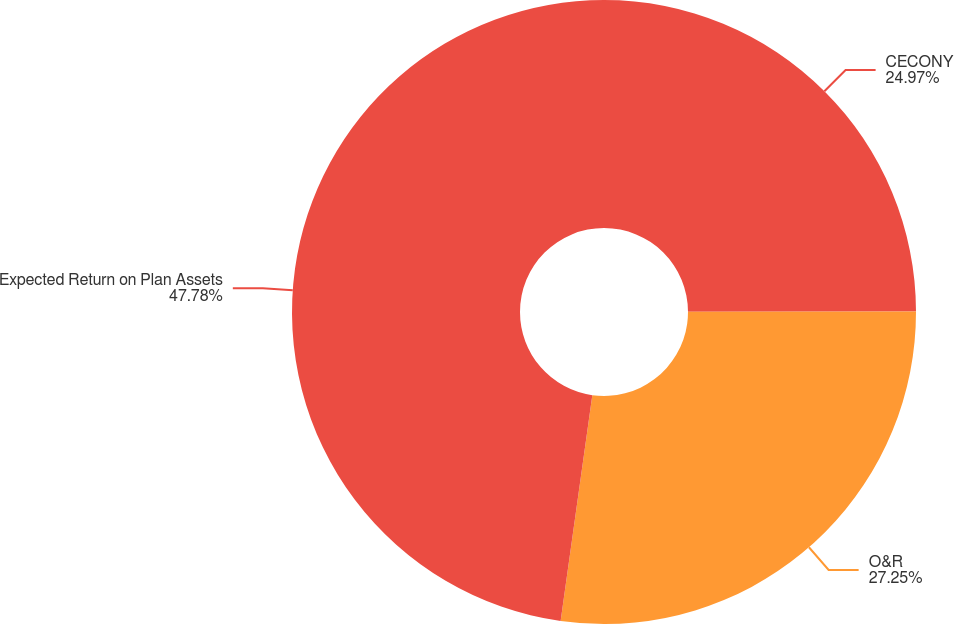Convert chart to OTSL. <chart><loc_0><loc_0><loc_500><loc_500><pie_chart><fcel>CECONY<fcel>O&R<fcel>Expected Return on Plan Assets<nl><fcel>24.97%<fcel>27.25%<fcel>47.78%<nl></chart> 